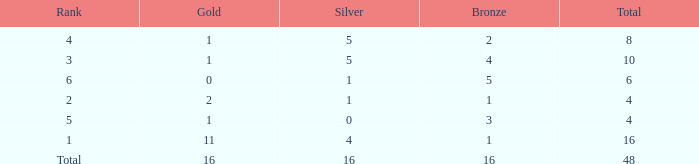What is the total gold that has bronze less than 2, a silver of 1 and total more than 4? None. 